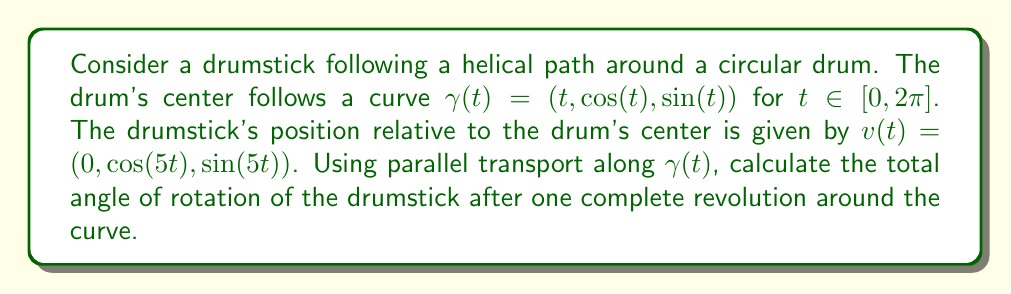Solve this math problem. To solve this problem, we'll follow these steps:

1) First, we need to calculate the tangent vector $T(t)$ to the curve $\gamma(t)$:
   $$T(t) = \gamma'(t) = (1, -\sin(t), \cos(t))$$

2) Next, we normalize $T(t)$ to get the unit tangent vector:
   $$T(t) = \frac{(1, -\sin(t), \cos(t))}{\sqrt{1 + \sin^2(t) + \cos^2(t)}} = \frac{(1, -\sin(t), \cos(t))}{\sqrt{2}}$$

3) The normal vector $N(t)$ is:
   $$N(t) = \frac{T'(t)}{|T'(t)|} = (0, -\cos(t), -\sin(t))$$

4) And the binormal vector $B(t)$ is:
   $$B(t) = T(t) \times N(t) = \frac{(1, \sin(t), -\cos(t))}{\sqrt{2}}$$

5) Now, we can express $v(t)$ in the Frenet frame:
   $$v(t) = 0 \cdot T(t) + \cos(5t) \cdot N(t) + \sin(5t) \cdot B(t)$$

6) The rotation of the Frenet frame is given by the torsion $\tau(t)$:
   $$\tau(t) = -\frac{d}{dt}B(t) \cdot N(t) = \frac{1}{\sqrt{2}}$$

7) The total angle of rotation after one revolution is:
   $$\theta = \int_0^{2\pi} \tau(t) dt = \frac{2\pi}{\sqrt{2}}$$

8) However, we also need to account for the rotation of $v(t)$ itself:
   $$\theta_{v} = 5 \cdot 2\pi = 10\pi$$

9) The total angle of rotation is the difference:
   $$\theta_{total} = \theta_{v} - \theta = 10\pi - \frac{2\pi}{\sqrt{2}}$$
Answer: $10\pi - \frac{2\pi}{\sqrt{2}}$ radians 